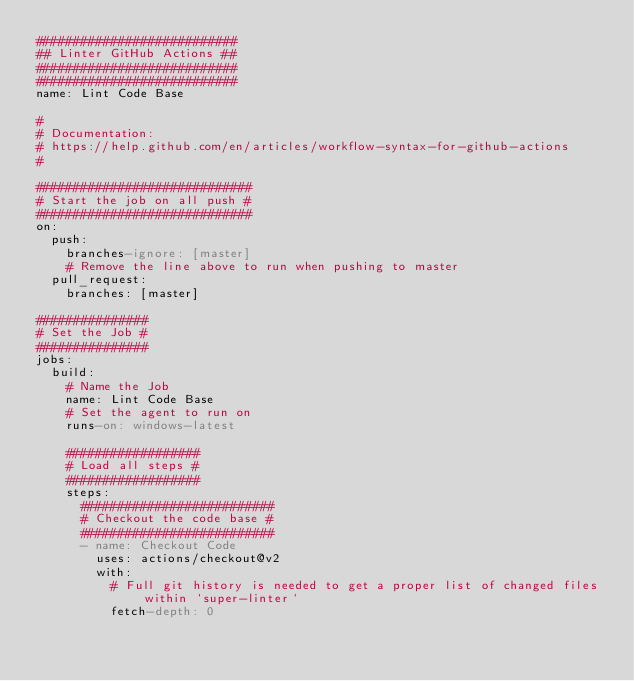Convert code to text. <code><loc_0><loc_0><loc_500><loc_500><_YAML_>###########################
## Linter GitHub Actions ##
###########################
###########################
name: Lint Code Base

#
# Documentation:
# https://help.github.com/en/articles/workflow-syntax-for-github-actions
#

#############################
# Start the job on all push #
#############################
on:
  push:
    branches-ignore: [master]
    # Remove the line above to run when pushing to master
  pull_request:
    branches: [master]

###############
# Set the Job #
###############
jobs:
  build:
    # Name the Job
    name: Lint Code Base
    # Set the agent to run on
    runs-on: windows-latest

    ##################
    # Load all steps #
    ##################
    steps:
      ##########################
      # Checkout the code base #
      ##########################
      - name: Checkout Code
        uses: actions/checkout@v2
        with:
          # Full git history is needed to get a proper list of changed files within `super-linter`
          fetch-depth: 0
</code> 